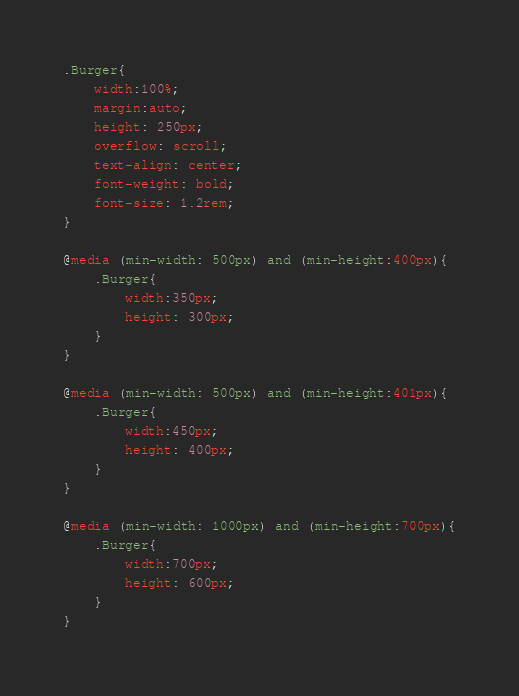Convert code to text. <code><loc_0><loc_0><loc_500><loc_500><_CSS_>.Burger{
    width:100%;
    margin:auto;
    height: 250px;
    overflow: scroll;
    text-align: center;
    font-weight: bold;
    font-size: 1.2rem;
}

@media (min-width: 500px) and (min-height:400px){
    .Burger{
        width:350px;
        height: 300px;
    }
}

@media (min-width: 500px) and (min-height:401px){
    .Burger{
        width:450px;
        height: 400px;
    }
}
  
@media (min-width: 1000px) and (min-height:700px){
    .Burger{
        width:700px;
        height: 600px;
    }
}</code> 